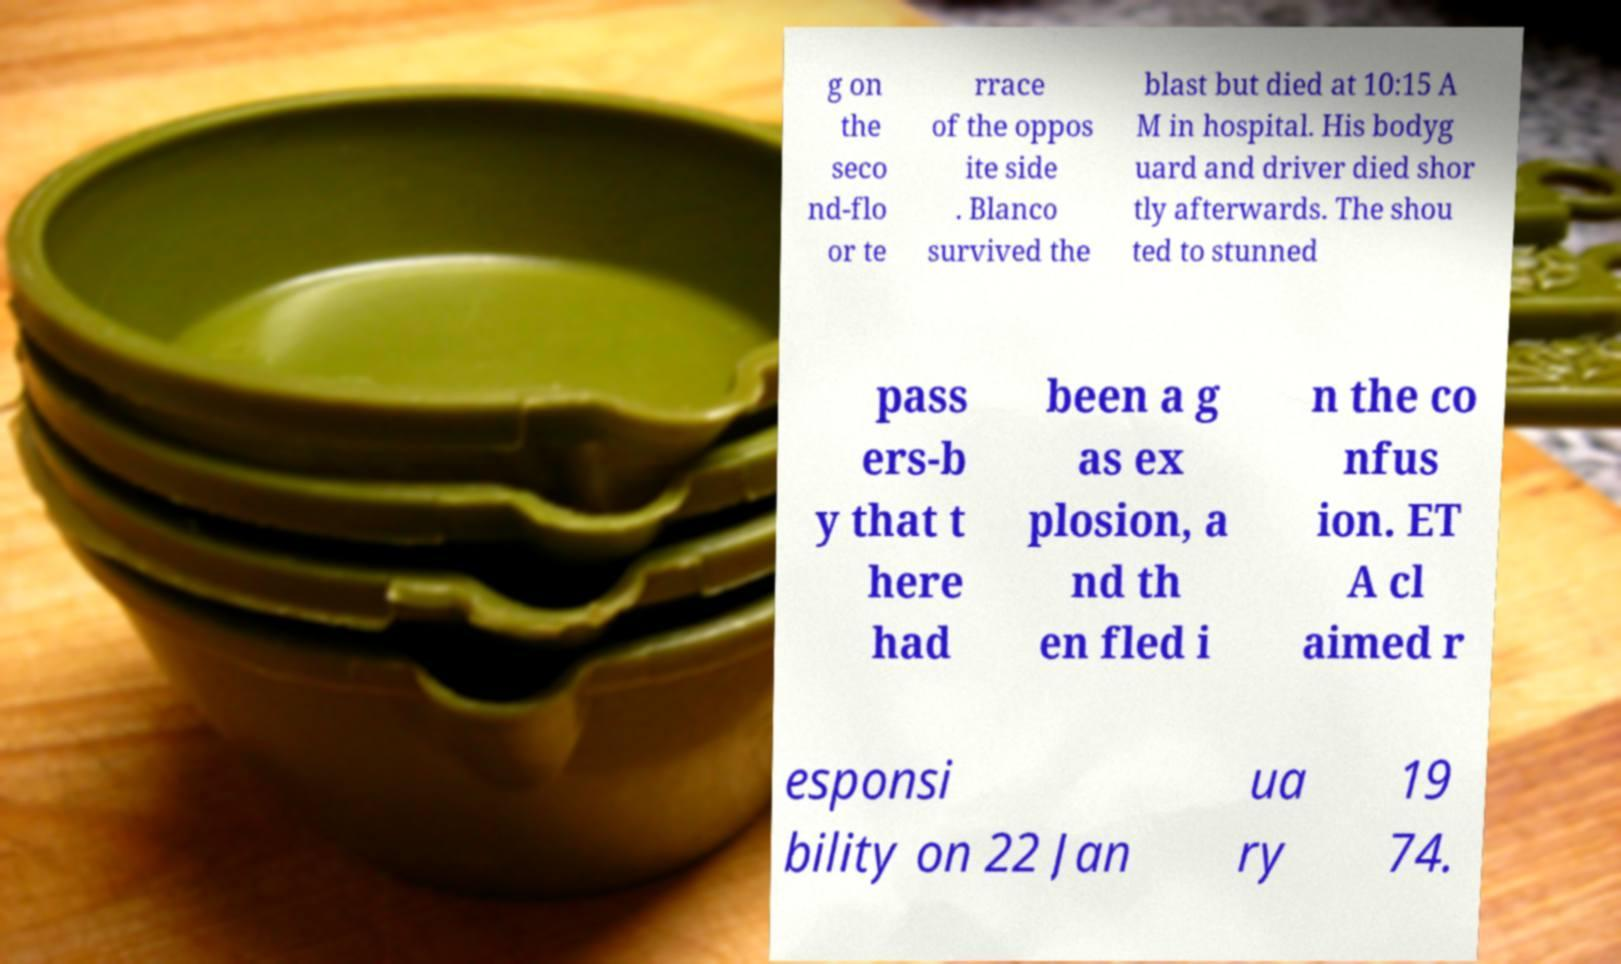There's text embedded in this image that I need extracted. Can you transcribe it verbatim? g on the seco nd-flo or te rrace of the oppos ite side . Blanco survived the blast but died at 10:15 A M in hospital. His bodyg uard and driver died shor tly afterwards. The shou ted to stunned pass ers-b y that t here had been a g as ex plosion, a nd th en fled i n the co nfus ion. ET A cl aimed r esponsi bility on 22 Jan ua ry 19 74. 